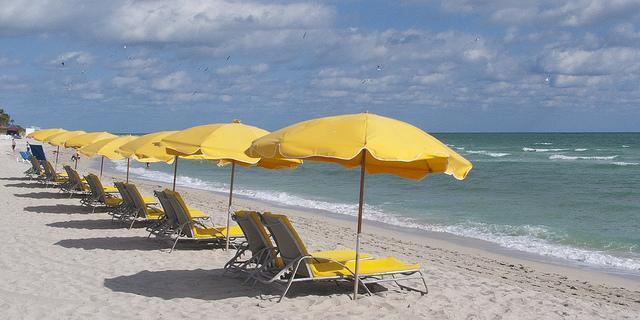How many people are sitting on beach chairs?
Give a very brief answer. 0. How many umbrellas are there?
Give a very brief answer. 2. How many chairs can you see?
Give a very brief answer. 2. How many red cars transporting bicycles to the left are there? there are red cars to the right transporting bicycles too?
Give a very brief answer. 0. 